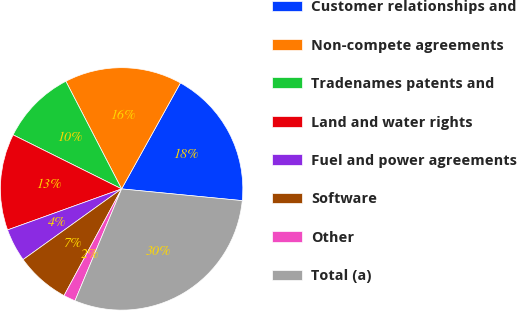Convert chart. <chart><loc_0><loc_0><loc_500><loc_500><pie_chart><fcel>Customer relationships and<fcel>Non-compete agreements<fcel>Tradenames patents and<fcel>Land and water rights<fcel>Fuel and power agreements<fcel>Software<fcel>Other<fcel>Total (a)<nl><fcel>18.48%<fcel>15.67%<fcel>10.04%<fcel>12.85%<fcel>4.41%<fcel>7.22%<fcel>1.59%<fcel>29.74%<nl></chart> 